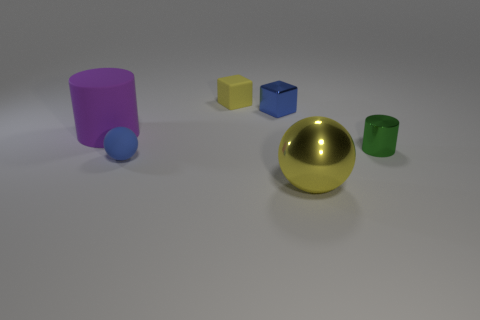What number of cylinders are in front of the large purple matte cylinder?
Ensure brevity in your answer.  1. Is the material of the small object that is in front of the green thing the same as the big object in front of the metal cylinder?
Ensure brevity in your answer.  No. Is the number of rubber cylinders left of the matte cylinder greater than the number of tiny matte things left of the tiny matte block?
Offer a very short reply. No. There is a ball that is the same color as the tiny matte block; what is its material?
Ensure brevity in your answer.  Metal. What material is the object that is both in front of the green cylinder and behind the yellow metallic sphere?
Give a very brief answer. Rubber. Does the big purple cylinder have the same material as the yellow object left of the small blue metal cube?
Provide a short and direct response. Yes. How many things are either tiny rubber things or blue objects on the right side of the tiny yellow matte cube?
Give a very brief answer. 3. There is a yellow thing behind the big yellow thing; is its size the same as the yellow object that is to the right of the small yellow thing?
Your answer should be compact. No. How many other objects are the same color as the metal block?
Keep it short and to the point. 1. There is a purple matte thing; is its size the same as the sphere on the right side of the tiny rubber sphere?
Provide a succinct answer. Yes. 